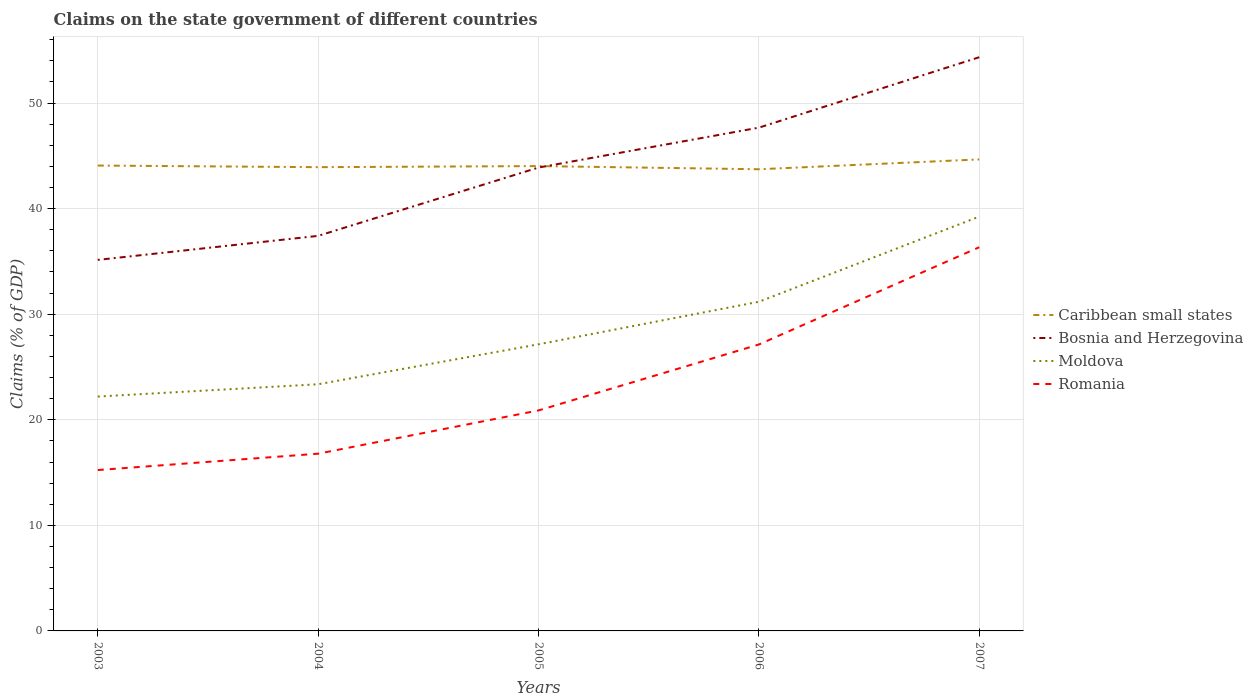Does the line corresponding to Moldova intersect with the line corresponding to Bosnia and Herzegovina?
Give a very brief answer. No. Across all years, what is the maximum percentage of GDP claimed on the state government in Romania?
Give a very brief answer. 15.24. In which year was the percentage of GDP claimed on the state government in Bosnia and Herzegovina maximum?
Offer a very short reply. 2003. What is the total percentage of GDP claimed on the state government in Romania in the graph?
Offer a very short reply. -6.25. What is the difference between the highest and the second highest percentage of GDP claimed on the state government in Caribbean small states?
Offer a very short reply. 0.93. What is the difference between the highest and the lowest percentage of GDP claimed on the state government in Bosnia and Herzegovina?
Your answer should be compact. 3. How many years are there in the graph?
Give a very brief answer. 5. What is the difference between two consecutive major ticks on the Y-axis?
Keep it short and to the point. 10. Where does the legend appear in the graph?
Make the answer very short. Center right. How many legend labels are there?
Ensure brevity in your answer.  4. How are the legend labels stacked?
Your response must be concise. Vertical. What is the title of the graph?
Ensure brevity in your answer.  Claims on the state government of different countries. What is the label or title of the X-axis?
Offer a terse response. Years. What is the label or title of the Y-axis?
Offer a very short reply. Claims (% of GDP). What is the Claims (% of GDP) of Caribbean small states in 2003?
Your response must be concise. 44.08. What is the Claims (% of GDP) of Bosnia and Herzegovina in 2003?
Make the answer very short. 35.15. What is the Claims (% of GDP) of Moldova in 2003?
Make the answer very short. 22.2. What is the Claims (% of GDP) in Romania in 2003?
Provide a succinct answer. 15.24. What is the Claims (% of GDP) in Caribbean small states in 2004?
Make the answer very short. 43.93. What is the Claims (% of GDP) of Bosnia and Herzegovina in 2004?
Offer a terse response. 37.42. What is the Claims (% of GDP) in Moldova in 2004?
Ensure brevity in your answer.  23.37. What is the Claims (% of GDP) in Romania in 2004?
Offer a terse response. 16.79. What is the Claims (% of GDP) of Caribbean small states in 2005?
Offer a very short reply. 44.03. What is the Claims (% of GDP) in Bosnia and Herzegovina in 2005?
Offer a very short reply. 43.89. What is the Claims (% of GDP) in Moldova in 2005?
Provide a short and direct response. 27.15. What is the Claims (% of GDP) of Romania in 2005?
Your answer should be very brief. 20.89. What is the Claims (% of GDP) in Caribbean small states in 2006?
Keep it short and to the point. 43.73. What is the Claims (% of GDP) of Bosnia and Herzegovina in 2006?
Offer a terse response. 47.67. What is the Claims (% of GDP) in Moldova in 2006?
Offer a terse response. 31.18. What is the Claims (% of GDP) of Romania in 2006?
Offer a very short reply. 27.13. What is the Claims (% of GDP) in Caribbean small states in 2007?
Offer a very short reply. 44.67. What is the Claims (% of GDP) in Bosnia and Herzegovina in 2007?
Provide a succinct answer. 54.35. What is the Claims (% of GDP) of Moldova in 2007?
Provide a short and direct response. 39.25. What is the Claims (% of GDP) in Romania in 2007?
Ensure brevity in your answer.  36.35. Across all years, what is the maximum Claims (% of GDP) in Caribbean small states?
Provide a short and direct response. 44.67. Across all years, what is the maximum Claims (% of GDP) of Bosnia and Herzegovina?
Your answer should be compact. 54.35. Across all years, what is the maximum Claims (% of GDP) in Moldova?
Provide a succinct answer. 39.25. Across all years, what is the maximum Claims (% of GDP) of Romania?
Give a very brief answer. 36.35. Across all years, what is the minimum Claims (% of GDP) in Caribbean small states?
Your answer should be very brief. 43.73. Across all years, what is the minimum Claims (% of GDP) in Bosnia and Herzegovina?
Offer a terse response. 35.15. Across all years, what is the minimum Claims (% of GDP) of Moldova?
Keep it short and to the point. 22.2. Across all years, what is the minimum Claims (% of GDP) of Romania?
Make the answer very short. 15.24. What is the total Claims (% of GDP) in Caribbean small states in the graph?
Keep it short and to the point. 220.45. What is the total Claims (% of GDP) of Bosnia and Herzegovina in the graph?
Make the answer very short. 218.48. What is the total Claims (% of GDP) in Moldova in the graph?
Your answer should be very brief. 143.15. What is the total Claims (% of GDP) of Romania in the graph?
Ensure brevity in your answer.  116.39. What is the difference between the Claims (% of GDP) in Caribbean small states in 2003 and that in 2004?
Ensure brevity in your answer.  0.15. What is the difference between the Claims (% of GDP) in Bosnia and Herzegovina in 2003 and that in 2004?
Provide a succinct answer. -2.28. What is the difference between the Claims (% of GDP) of Moldova in 2003 and that in 2004?
Provide a short and direct response. -1.16. What is the difference between the Claims (% of GDP) of Romania in 2003 and that in 2004?
Ensure brevity in your answer.  -1.55. What is the difference between the Claims (% of GDP) of Bosnia and Herzegovina in 2003 and that in 2005?
Your response must be concise. -8.75. What is the difference between the Claims (% of GDP) in Moldova in 2003 and that in 2005?
Provide a succinct answer. -4.95. What is the difference between the Claims (% of GDP) of Romania in 2003 and that in 2005?
Offer a terse response. -5.65. What is the difference between the Claims (% of GDP) of Caribbean small states in 2003 and that in 2006?
Your answer should be very brief. 0.35. What is the difference between the Claims (% of GDP) in Bosnia and Herzegovina in 2003 and that in 2006?
Your answer should be compact. -12.53. What is the difference between the Claims (% of GDP) in Moldova in 2003 and that in 2006?
Provide a succinct answer. -8.98. What is the difference between the Claims (% of GDP) in Romania in 2003 and that in 2006?
Offer a terse response. -11.89. What is the difference between the Claims (% of GDP) of Caribbean small states in 2003 and that in 2007?
Your response must be concise. -0.58. What is the difference between the Claims (% of GDP) of Bosnia and Herzegovina in 2003 and that in 2007?
Your response must be concise. -19.2. What is the difference between the Claims (% of GDP) in Moldova in 2003 and that in 2007?
Keep it short and to the point. -17.05. What is the difference between the Claims (% of GDP) of Romania in 2003 and that in 2007?
Keep it short and to the point. -21.11. What is the difference between the Claims (% of GDP) in Caribbean small states in 2004 and that in 2005?
Keep it short and to the point. -0.1. What is the difference between the Claims (% of GDP) in Bosnia and Herzegovina in 2004 and that in 2005?
Ensure brevity in your answer.  -6.47. What is the difference between the Claims (% of GDP) in Moldova in 2004 and that in 2005?
Provide a succinct answer. -3.78. What is the difference between the Claims (% of GDP) in Romania in 2004 and that in 2005?
Offer a terse response. -4.1. What is the difference between the Claims (% of GDP) of Caribbean small states in 2004 and that in 2006?
Offer a very short reply. 0.2. What is the difference between the Claims (% of GDP) of Bosnia and Herzegovina in 2004 and that in 2006?
Offer a very short reply. -10.25. What is the difference between the Claims (% of GDP) of Moldova in 2004 and that in 2006?
Your response must be concise. -7.82. What is the difference between the Claims (% of GDP) in Romania in 2004 and that in 2006?
Provide a short and direct response. -10.34. What is the difference between the Claims (% of GDP) in Caribbean small states in 2004 and that in 2007?
Provide a short and direct response. -0.74. What is the difference between the Claims (% of GDP) of Bosnia and Herzegovina in 2004 and that in 2007?
Ensure brevity in your answer.  -16.92. What is the difference between the Claims (% of GDP) of Moldova in 2004 and that in 2007?
Provide a short and direct response. -15.88. What is the difference between the Claims (% of GDP) of Romania in 2004 and that in 2007?
Your answer should be very brief. -19.56. What is the difference between the Claims (% of GDP) in Caribbean small states in 2005 and that in 2006?
Your answer should be very brief. 0.3. What is the difference between the Claims (% of GDP) in Bosnia and Herzegovina in 2005 and that in 2006?
Provide a succinct answer. -3.78. What is the difference between the Claims (% of GDP) of Moldova in 2005 and that in 2006?
Your answer should be very brief. -4.03. What is the difference between the Claims (% of GDP) in Romania in 2005 and that in 2006?
Your answer should be very brief. -6.25. What is the difference between the Claims (% of GDP) in Caribbean small states in 2005 and that in 2007?
Provide a succinct answer. -0.63. What is the difference between the Claims (% of GDP) in Bosnia and Herzegovina in 2005 and that in 2007?
Ensure brevity in your answer.  -10.45. What is the difference between the Claims (% of GDP) in Moldova in 2005 and that in 2007?
Offer a terse response. -12.1. What is the difference between the Claims (% of GDP) in Romania in 2005 and that in 2007?
Your response must be concise. -15.46. What is the difference between the Claims (% of GDP) of Caribbean small states in 2006 and that in 2007?
Make the answer very short. -0.93. What is the difference between the Claims (% of GDP) of Bosnia and Herzegovina in 2006 and that in 2007?
Provide a short and direct response. -6.67. What is the difference between the Claims (% of GDP) in Moldova in 2006 and that in 2007?
Keep it short and to the point. -8.07. What is the difference between the Claims (% of GDP) in Romania in 2006 and that in 2007?
Offer a terse response. -9.21. What is the difference between the Claims (% of GDP) in Caribbean small states in 2003 and the Claims (% of GDP) in Bosnia and Herzegovina in 2004?
Your answer should be very brief. 6.66. What is the difference between the Claims (% of GDP) in Caribbean small states in 2003 and the Claims (% of GDP) in Moldova in 2004?
Keep it short and to the point. 20.72. What is the difference between the Claims (% of GDP) of Caribbean small states in 2003 and the Claims (% of GDP) of Romania in 2004?
Give a very brief answer. 27.29. What is the difference between the Claims (% of GDP) in Bosnia and Herzegovina in 2003 and the Claims (% of GDP) in Moldova in 2004?
Offer a very short reply. 11.78. What is the difference between the Claims (% of GDP) of Bosnia and Herzegovina in 2003 and the Claims (% of GDP) of Romania in 2004?
Provide a short and direct response. 18.36. What is the difference between the Claims (% of GDP) in Moldova in 2003 and the Claims (% of GDP) in Romania in 2004?
Offer a terse response. 5.41. What is the difference between the Claims (% of GDP) of Caribbean small states in 2003 and the Claims (% of GDP) of Bosnia and Herzegovina in 2005?
Provide a short and direct response. 0.19. What is the difference between the Claims (% of GDP) in Caribbean small states in 2003 and the Claims (% of GDP) in Moldova in 2005?
Offer a very short reply. 16.93. What is the difference between the Claims (% of GDP) of Caribbean small states in 2003 and the Claims (% of GDP) of Romania in 2005?
Offer a terse response. 23.2. What is the difference between the Claims (% of GDP) in Bosnia and Herzegovina in 2003 and the Claims (% of GDP) in Moldova in 2005?
Keep it short and to the point. 8. What is the difference between the Claims (% of GDP) of Bosnia and Herzegovina in 2003 and the Claims (% of GDP) of Romania in 2005?
Offer a very short reply. 14.26. What is the difference between the Claims (% of GDP) in Moldova in 2003 and the Claims (% of GDP) in Romania in 2005?
Your answer should be compact. 1.31. What is the difference between the Claims (% of GDP) in Caribbean small states in 2003 and the Claims (% of GDP) in Bosnia and Herzegovina in 2006?
Keep it short and to the point. -3.59. What is the difference between the Claims (% of GDP) in Caribbean small states in 2003 and the Claims (% of GDP) in Moldova in 2006?
Provide a succinct answer. 12.9. What is the difference between the Claims (% of GDP) in Caribbean small states in 2003 and the Claims (% of GDP) in Romania in 2006?
Make the answer very short. 16.95. What is the difference between the Claims (% of GDP) in Bosnia and Herzegovina in 2003 and the Claims (% of GDP) in Moldova in 2006?
Your answer should be very brief. 3.97. What is the difference between the Claims (% of GDP) of Bosnia and Herzegovina in 2003 and the Claims (% of GDP) of Romania in 2006?
Keep it short and to the point. 8.01. What is the difference between the Claims (% of GDP) of Moldova in 2003 and the Claims (% of GDP) of Romania in 2006?
Give a very brief answer. -4.93. What is the difference between the Claims (% of GDP) of Caribbean small states in 2003 and the Claims (% of GDP) of Bosnia and Herzegovina in 2007?
Keep it short and to the point. -10.26. What is the difference between the Claims (% of GDP) in Caribbean small states in 2003 and the Claims (% of GDP) in Moldova in 2007?
Give a very brief answer. 4.84. What is the difference between the Claims (% of GDP) of Caribbean small states in 2003 and the Claims (% of GDP) of Romania in 2007?
Give a very brief answer. 7.74. What is the difference between the Claims (% of GDP) in Bosnia and Herzegovina in 2003 and the Claims (% of GDP) in Moldova in 2007?
Make the answer very short. -4.1. What is the difference between the Claims (% of GDP) in Bosnia and Herzegovina in 2003 and the Claims (% of GDP) in Romania in 2007?
Your response must be concise. -1.2. What is the difference between the Claims (% of GDP) in Moldova in 2003 and the Claims (% of GDP) in Romania in 2007?
Offer a very short reply. -14.15. What is the difference between the Claims (% of GDP) of Caribbean small states in 2004 and the Claims (% of GDP) of Bosnia and Herzegovina in 2005?
Keep it short and to the point. 0.04. What is the difference between the Claims (% of GDP) in Caribbean small states in 2004 and the Claims (% of GDP) in Moldova in 2005?
Ensure brevity in your answer.  16.78. What is the difference between the Claims (% of GDP) in Caribbean small states in 2004 and the Claims (% of GDP) in Romania in 2005?
Make the answer very short. 23.04. What is the difference between the Claims (% of GDP) of Bosnia and Herzegovina in 2004 and the Claims (% of GDP) of Moldova in 2005?
Keep it short and to the point. 10.27. What is the difference between the Claims (% of GDP) of Bosnia and Herzegovina in 2004 and the Claims (% of GDP) of Romania in 2005?
Your answer should be compact. 16.54. What is the difference between the Claims (% of GDP) of Moldova in 2004 and the Claims (% of GDP) of Romania in 2005?
Ensure brevity in your answer.  2.48. What is the difference between the Claims (% of GDP) in Caribbean small states in 2004 and the Claims (% of GDP) in Bosnia and Herzegovina in 2006?
Provide a succinct answer. -3.74. What is the difference between the Claims (% of GDP) in Caribbean small states in 2004 and the Claims (% of GDP) in Moldova in 2006?
Ensure brevity in your answer.  12.75. What is the difference between the Claims (% of GDP) in Caribbean small states in 2004 and the Claims (% of GDP) in Romania in 2006?
Your answer should be very brief. 16.8. What is the difference between the Claims (% of GDP) in Bosnia and Herzegovina in 2004 and the Claims (% of GDP) in Moldova in 2006?
Offer a very short reply. 6.24. What is the difference between the Claims (% of GDP) in Bosnia and Herzegovina in 2004 and the Claims (% of GDP) in Romania in 2006?
Provide a succinct answer. 10.29. What is the difference between the Claims (% of GDP) of Moldova in 2004 and the Claims (% of GDP) of Romania in 2006?
Your answer should be compact. -3.77. What is the difference between the Claims (% of GDP) in Caribbean small states in 2004 and the Claims (% of GDP) in Bosnia and Herzegovina in 2007?
Your answer should be very brief. -10.42. What is the difference between the Claims (% of GDP) of Caribbean small states in 2004 and the Claims (% of GDP) of Moldova in 2007?
Offer a terse response. 4.68. What is the difference between the Claims (% of GDP) of Caribbean small states in 2004 and the Claims (% of GDP) of Romania in 2007?
Ensure brevity in your answer.  7.58. What is the difference between the Claims (% of GDP) of Bosnia and Herzegovina in 2004 and the Claims (% of GDP) of Moldova in 2007?
Offer a terse response. -1.82. What is the difference between the Claims (% of GDP) in Bosnia and Herzegovina in 2004 and the Claims (% of GDP) in Romania in 2007?
Offer a very short reply. 1.08. What is the difference between the Claims (% of GDP) of Moldova in 2004 and the Claims (% of GDP) of Romania in 2007?
Provide a succinct answer. -12.98. What is the difference between the Claims (% of GDP) in Caribbean small states in 2005 and the Claims (% of GDP) in Bosnia and Herzegovina in 2006?
Give a very brief answer. -3.64. What is the difference between the Claims (% of GDP) of Caribbean small states in 2005 and the Claims (% of GDP) of Moldova in 2006?
Offer a terse response. 12.85. What is the difference between the Claims (% of GDP) of Caribbean small states in 2005 and the Claims (% of GDP) of Romania in 2006?
Your answer should be very brief. 16.9. What is the difference between the Claims (% of GDP) in Bosnia and Herzegovina in 2005 and the Claims (% of GDP) in Moldova in 2006?
Your answer should be compact. 12.71. What is the difference between the Claims (% of GDP) in Bosnia and Herzegovina in 2005 and the Claims (% of GDP) in Romania in 2006?
Make the answer very short. 16.76. What is the difference between the Claims (% of GDP) of Moldova in 2005 and the Claims (% of GDP) of Romania in 2006?
Make the answer very short. 0.02. What is the difference between the Claims (% of GDP) in Caribbean small states in 2005 and the Claims (% of GDP) in Bosnia and Herzegovina in 2007?
Make the answer very short. -10.31. What is the difference between the Claims (% of GDP) of Caribbean small states in 2005 and the Claims (% of GDP) of Moldova in 2007?
Give a very brief answer. 4.79. What is the difference between the Claims (% of GDP) of Caribbean small states in 2005 and the Claims (% of GDP) of Romania in 2007?
Offer a very short reply. 7.69. What is the difference between the Claims (% of GDP) in Bosnia and Herzegovina in 2005 and the Claims (% of GDP) in Moldova in 2007?
Your response must be concise. 4.65. What is the difference between the Claims (% of GDP) of Bosnia and Herzegovina in 2005 and the Claims (% of GDP) of Romania in 2007?
Provide a short and direct response. 7.55. What is the difference between the Claims (% of GDP) in Moldova in 2005 and the Claims (% of GDP) in Romania in 2007?
Ensure brevity in your answer.  -9.2. What is the difference between the Claims (% of GDP) of Caribbean small states in 2006 and the Claims (% of GDP) of Bosnia and Herzegovina in 2007?
Your response must be concise. -10.61. What is the difference between the Claims (% of GDP) in Caribbean small states in 2006 and the Claims (% of GDP) in Moldova in 2007?
Your answer should be compact. 4.49. What is the difference between the Claims (% of GDP) in Caribbean small states in 2006 and the Claims (% of GDP) in Romania in 2007?
Offer a very short reply. 7.39. What is the difference between the Claims (% of GDP) of Bosnia and Herzegovina in 2006 and the Claims (% of GDP) of Moldova in 2007?
Make the answer very short. 8.43. What is the difference between the Claims (% of GDP) in Bosnia and Herzegovina in 2006 and the Claims (% of GDP) in Romania in 2007?
Offer a terse response. 11.33. What is the difference between the Claims (% of GDP) of Moldova in 2006 and the Claims (% of GDP) of Romania in 2007?
Give a very brief answer. -5.17. What is the average Claims (% of GDP) of Caribbean small states per year?
Your answer should be very brief. 44.09. What is the average Claims (% of GDP) of Bosnia and Herzegovina per year?
Make the answer very short. 43.7. What is the average Claims (% of GDP) of Moldova per year?
Ensure brevity in your answer.  28.63. What is the average Claims (% of GDP) in Romania per year?
Your response must be concise. 23.28. In the year 2003, what is the difference between the Claims (% of GDP) of Caribbean small states and Claims (% of GDP) of Bosnia and Herzegovina?
Your answer should be compact. 8.94. In the year 2003, what is the difference between the Claims (% of GDP) in Caribbean small states and Claims (% of GDP) in Moldova?
Give a very brief answer. 21.88. In the year 2003, what is the difference between the Claims (% of GDP) of Caribbean small states and Claims (% of GDP) of Romania?
Ensure brevity in your answer.  28.85. In the year 2003, what is the difference between the Claims (% of GDP) in Bosnia and Herzegovina and Claims (% of GDP) in Moldova?
Your response must be concise. 12.95. In the year 2003, what is the difference between the Claims (% of GDP) of Bosnia and Herzegovina and Claims (% of GDP) of Romania?
Your answer should be very brief. 19.91. In the year 2003, what is the difference between the Claims (% of GDP) in Moldova and Claims (% of GDP) in Romania?
Offer a very short reply. 6.96. In the year 2004, what is the difference between the Claims (% of GDP) of Caribbean small states and Claims (% of GDP) of Bosnia and Herzegovina?
Offer a terse response. 6.51. In the year 2004, what is the difference between the Claims (% of GDP) in Caribbean small states and Claims (% of GDP) in Moldova?
Offer a very short reply. 20.56. In the year 2004, what is the difference between the Claims (% of GDP) in Caribbean small states and Claims (% of GDP) in Romania?
Offer a terse response. 27.14. In the year 2004, what is the difference between the Claims (% of GDP) in Bosnia and Herzegovina and Claims (% of GDP) in Moldova?
Your answer should be very brief. 14.06. In the year 2004, what is the difference between the Claims (% of GDP) of Bosnia and Herzegovina and Claims (% of GDP) of Romania?
Make the answer very short. 20.63. In the year 2004, what is the difference between the Claims (% of GDP) in Moldova and Claims (% of GDP) in Romania?
Your answer should be very brief. 6.58. In the year 2005, what is the difference between the Claims (% of GDP) of Caribbean small states and Claims (% of GDP) of Bosnia and Herzegovina?
Your response must be concise. 0.14. In the year 2005, what is the difference between the Claims (% of GDP) of Caribbean small states and Claims (% of GDP) of Moldova?
Your answer should be very brief. 16.88. In the year 2005, what is the difference between the Claims (% of GDP) of Caribbean small states and Claims (% of GDP) of Romania?
Provide a succinct answer. 23.15. In the year 2005, what is the difference between the Claims (% of GDP) of Bosnia and Herzegovina and Claims (% of GDP) of Moldova?
Keep it short and to the point. 16.74. In the year 2005, what is the difference between the Claims (% of GDP) of Bosnia and Herzegovina and Claims (% of GDP) of Romania?
Your answer should be compact. 23.01. In the year 2005, what is the difference between the Claims (% of GDP) in Moldova and Claims (% of GDP) in Romania?
Provide a short and direct response. 6.26. In the year 2006, what is the difference between the Claims (% of GDP) in Caribbean small states and Claims (% of GDP) in Bosnia and Herzegovina?
Provide a succinct answer. -3.94. In the year 2006, what is the difference between the Claims (% of GDP) in Caribbean small states and Claims (% of GDP) in Moldova?
Ensure brevity in your answer.  12.55. In the year 2006, what is the difference between the Claims (% of GDP) in Caribbean small states and Claims (% of GDP) in Romania?
Provide a short and direct response. 16.6. In the year 2006, what is the difference between the Claims (% of GDP) in Bosnia and Herzegovina and Claims (% of GDP) in Moldova?
Your response must be concise. 16.49. In the year 2006, what is the difference between the Claims (% of GDP) in Bosnia and Herzegovina and Claims (% of GDP) in Romania?
Ensure brevity in your answer.  20.54. In the year 2006, what is the difference between the Claims (% of GDP) of Moldova and Claims (% of GDP) of Romania?
Provide a succinct answer. 4.05. In the year 2007, what is the difference between the Claims (% of GDP) of Caribbean small states and Claims (% of GDP) of Bosnia and Herzegovina?
Ensure brevity in your answer.  -9.68. In the year 2007, what is the difference between the Claims (% of GDP) of Caribbean small states and Claims (% of GDP) of Moldova?
Your response must be concise. 5.42. In the year 2007, what is the difference between the Claims (% of GDP) of Caribbean small states and Claims (% of GDP) of Romania?
Your response must be concise. 8.32. In the year 2007, what is the difference between the Claims (% of GDP) of Bosnia and Herzegovina and Claims (% of GDP) of Moldova?
Give a very brief answer. 15.1. In the year 2007, what is the difference between the Claims (% of GDP) in Bosnia and Herzegovina and Claims (% of GDP) in Romania?
Your response must be concise. 18. In the year 2007, what is the difference between the Claims (% of GDP) in Moldova and Claims (% of GDP) in Romania?
Your answer should be very brief. 2.9. What is the ratio of the Claims (% of GDP) in Caribbean small states in 2003 to that in 2004?
Offer a terse response. 1. What is the ratio of the Claims (% of GDP) of Bosnia and Herzegovina in 2003 to that in 2004?
Your answer should be very brief. 0.94. What is the ratio of the Claims (% of GDP) of Moldova in 2003 to that in 2004?
Provide a short and direct response. 0.95. What is the ratio of the Claims (% of GDP) in Romania in 2003 to that in 2004?
Ensure brevity in your answer.  0.91. What is the ratio of the Claims (% of GDP) of Caribbean small states in 2003 to that in 2005?
Offer a very short reply. 1. What is the ratio of the Claims (% of GDP) in Bosnia and Herzegovina in 2003 to that in 2005?
Offer a terse response. 0.8. What is the ratio of the Claims (% of GDP) in Moldova in 2003 to that in 2005?
Your answer should be very brief. 0.82. What is the ratio of the Claims (% of GDP) of Romania in 2003 to that in 2005?
Your answer should be very brief. 0.73. What is the ratio of the Claims (% of GDP) in Caribbean small states in 2003 to that in 2006?
Offer a terse response. 1.01. What is the ratio of the Claims (% of GDP) of Bosnia and Herzegovina in 2003 to that in 2006?
Give a very brief answer. 0.74. What is the ratio of the Claims (% of GDP) of Moldova in 2003 to that in 2006?
Give a very brief answer. 0.71. What is the ratio of the Claims (% of GDP) of Romania in 2003 to that in 2006?
Provide a succinct answer. 0.56. What is the ratio of the Claims (% of GDP) in Caribbean small states in 2003 to that in 2007?
Offer a terse response. 0.99. What is the ratio of the Claims (% of GDP) of Bosnia and Herzegovina in 2003 to that in 2007?
Offer a terse response. 0.65. What is the ratio of the Claims (% of GDP) of Moldova in 2003 to that in 2007?
Offer a terse response. 0.57. What is the ratio of the Claims (% of GDP) in Romania in 2003 to that in 2007?
Give a very brief answer. 0.42. What is the ratio of the Claims (% of GDP) in Caribbean small states in 2004 to that in 2005?
Give a very brief answer. 1. What is the ratio of the Claims (% of GDP) of Bosnia and Herzegovina in 2004 to that in 2005?
Give a very brief answer. 0.85. What is the ratio of the Claims (% of GDP) of Moldova in 2004 to that in 2005?
Your answer should be compact. 0.86. What is the ratio of the Claims (% of GDP) in Romania in 2004 to that in 2005?
Your answer should be very brief. 0.8. What is the ratio of the Claims (% of GDP) in Caribbean small states in 2004 to that in 2006?
Your answer should be very brief. 1. What is the ratio of the Claims (% of GDP) in Bosnia and Herzegovina in 2004 to that in 2006?
Keep it short and to the point. 0.79. What is the ratio of the Claims (% of GDP) in Moldova in 2004 to that in 2006?
Your response must be concise. 0.75. What is the ratio of the Claims (% of GDP) of Romania in 2004 to that in 2006?
Ensure brevity in your answer.  0.62. What is the ratio of the Claims (% of GDP) in Caribbean small states in 2004 to that in 2007?
Make the answer very short. 0.98. What is the ratio of the Claims (% of GDP) of Bosnia and Herzegovina in 2004 to that in 2007?
Offer a terse response. 0.69. What is the ratio of the Claims (% of GDP) in Moldova in 2004 to that in 2007?
Your answer should be compact. 0.6. What is the ratio of the Claims (% of GDP) in Romania in 2004 to that in 2007?
Your answer should be very brief. 0.46. What is the ratio of the Claims (% of GDP) in Bosnia and Herzegovina in 2005 to that in 2006?
Your answer should be very brief. 0.92. What is the ratio of the Claims (% of GDP) of Moldova in 2005 to that in 2006?
Make the answer very short. 0.87. What is the ratio of the Claims (% of GDP) of Romania in 2005 to that in 2006?
Your answer should be compact. 0.77. What is the ratio of the Claims (% of GDP) of Caribbean small states in 2005 to that in 2007?
Your answer should be compact. 0.99. What is the ratio of the Claims (% of GDP) of Bosnia and Herzegovina in 2005 to that in 2007?
Keep it short and to the point. 0.81. What is the ratio of the Claims (% of GDP) in Moldova in 2005 to that in 2007?
Keep it short and to the point. 0.69. What is the ratio of the Claims (% of GDP) of Romania in 2005 to that in 2007?
Your answer should be compact. 0.57. What is the ratio of the Claims (% of GDP) in Caribbean small states in 2006 to that in 2007?
Provide a short and direct response. 0.98. What is the ratio of the Claims (% of GDP) in Bosnia and Herzegovina in 2006 to that in 2007?
Give a very brief answer. 0.88. What is the ratio of the Claims (% of GDP) in Moldova in 2006 to that in 2007?
Offer a terse response. 0.79. What is the ratio of the Claims (% of GDP) in Romania in 2006 to that in 2007?
Give a very brief answer. 0.75. What is the difference between the highest and the second highest Claims (% of GDP) of Caribbean small states?
Make the answer very short. 0.58. What is the difference between the highest and the second highest Claims (% of GDP) of Bosnia and Herzegovina?
Offer a terse response. 6.67. What is the difference between the highest and the second highest Claims (% of GDP) in Moldova?
Your answer should be very brief. 8.07. What is the difference between the highest and the second highest Claims (% of GDP) in Romania?
Keep it short and to the point. 9.21. What is the difference between the highest and the lowest Claims (% of GDP) of Caribbean small states?
Provide a short and direct response. 0.93. What is the difference between the highest and the lowest Claims (% of GDP) of Bosnia and Herzegovina?
Provide a short and direct response. 19.2. What is the difference between the highest and the lowest Claims (% of GDP) of Moldova?
Provide a short and direct response. 17.05. What is the difference between the highest and the lowest Claims (% of GDP) in Romania?
Give a very brief answer. 21.11. 